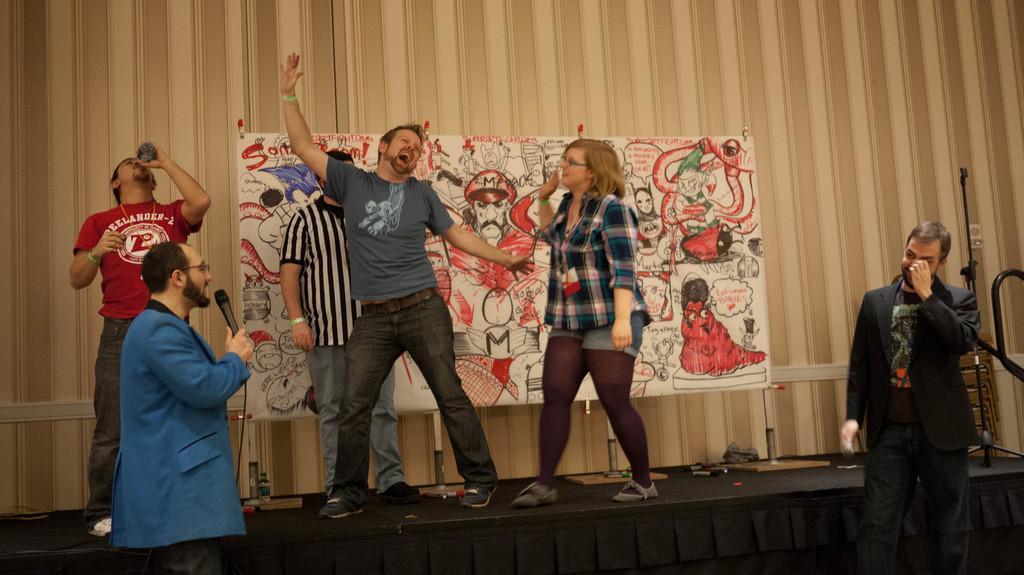In one or two sentences, can you explain what this image depicts? In the picture I can see few people are in one place, among them one person is holding microphone, another person is holding bottle, behind we can see a banner to the wall. 